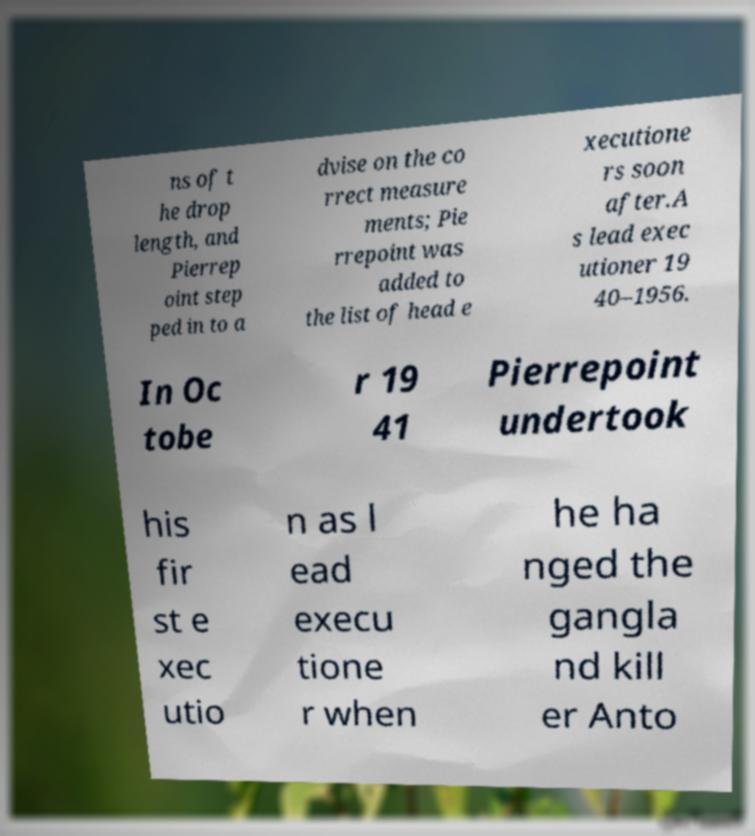Could you extract and type out the text from this image? ns of t he drop length, and Pierrep oint step ped in to a dvise on the co rrect measure ments; Pie rrepoint was added to the list of head e xecutione rs soon after.A s lead exec utioner 19 40–1956. In Oc tobe r 19 41 Pierrepoint undertook his fir st e xec utio n as l ead execu tione r when he ha nged the gangla nd kill er Anto 